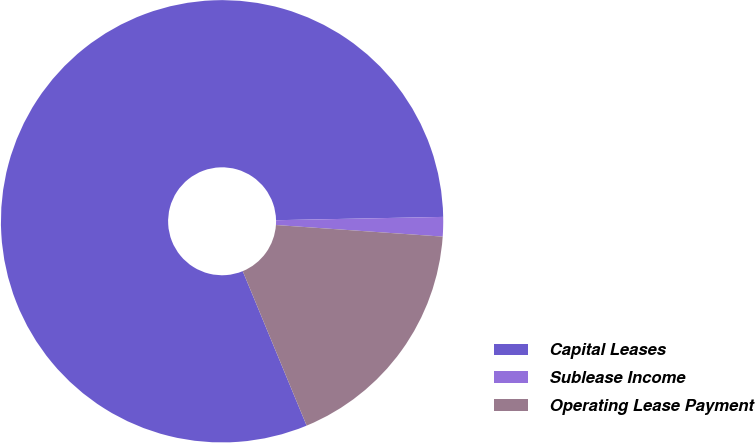Convert chart to OTSL. <chart><loc_0><loc_0><loc_500><loc_500><pie_chart><fcel>Capital Leases<fcel>Sublease Income<fcel>Operating Lease Payment<nl><fcel>80.92%<fcel>1.42%<fcel>17.65%<nl></chart> 